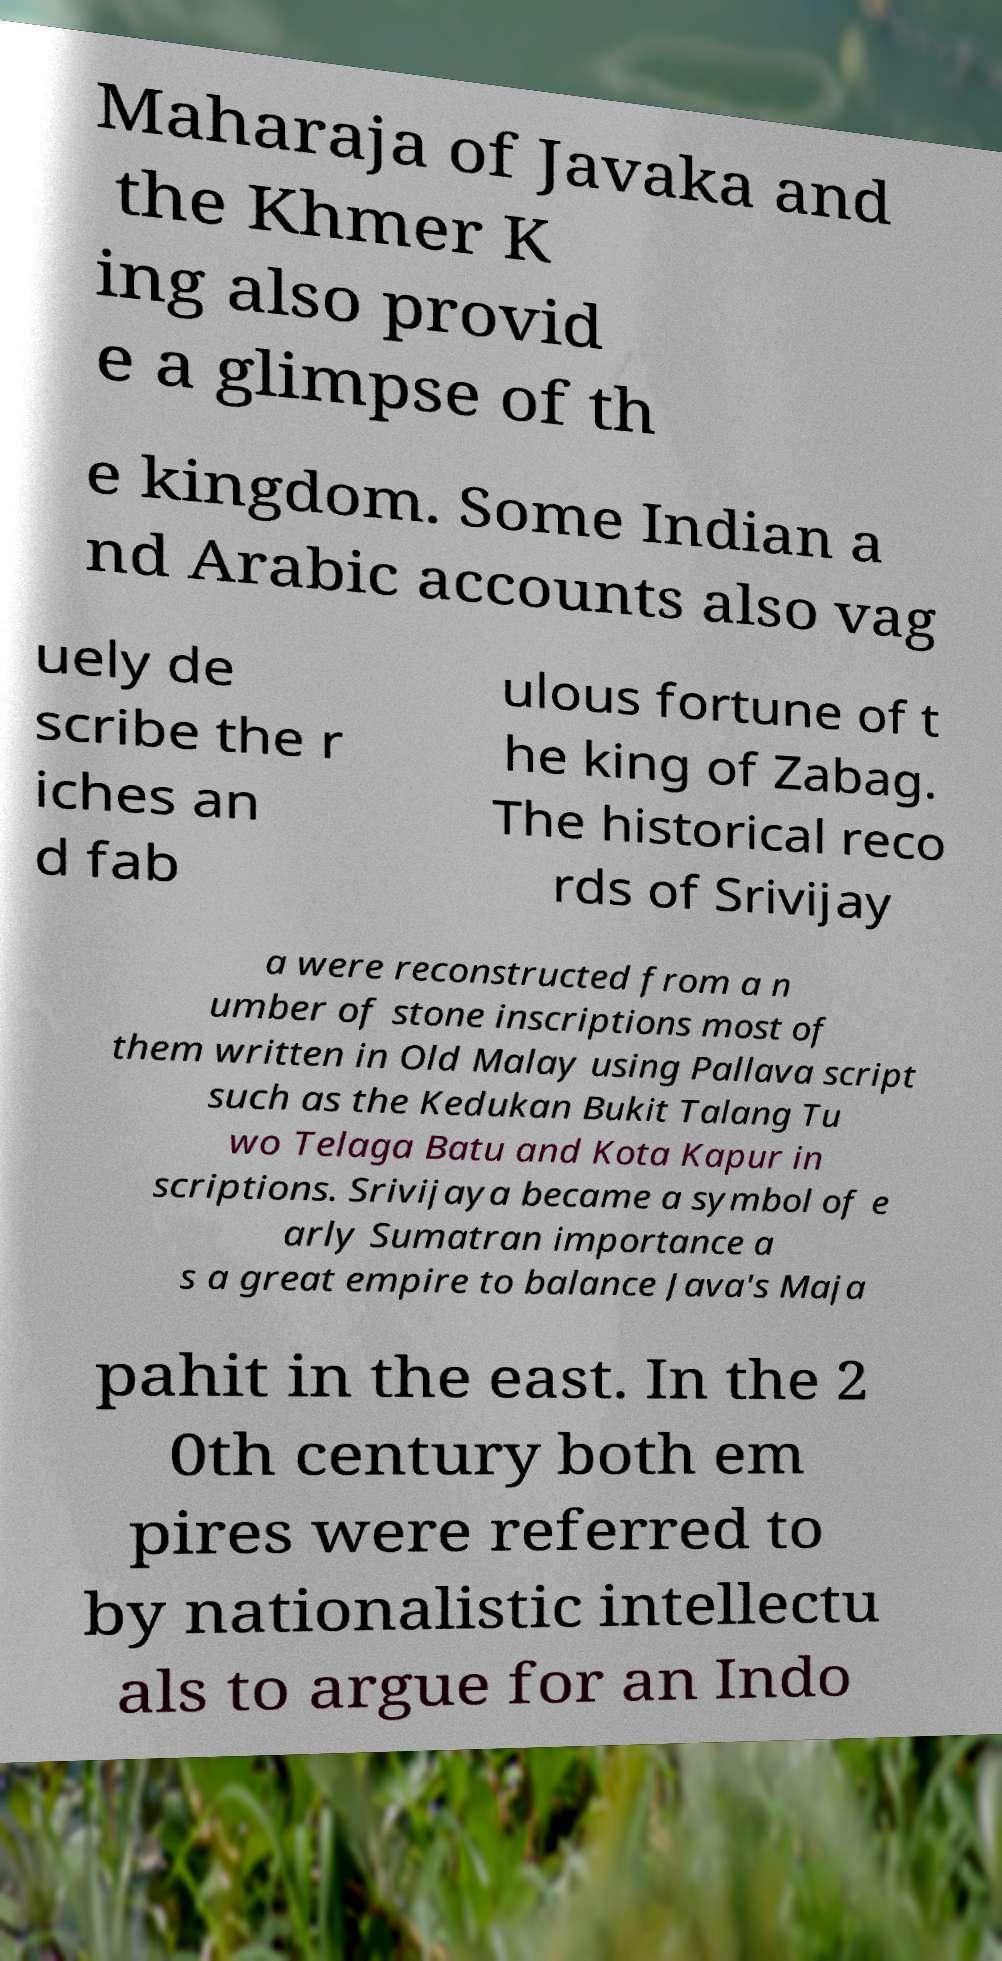What messages or text are displayed in this image? I need them in a readable, typed format. Maharaja of Javaka and the Khmer K ing also provid e a glimpse of th e kingdom. Some Indian a nd Arabic accounts also vag uely de scribe the r iches an d fab ulous fortune of t he king of Zabag. The historical reco rds of Srivijay a were reconstructed from a n umber of stone inscriptions most of them written in Old Malay using Pallava script such as the Kedukan Bukit Talang Tu wo Telaga Batu and Kota Kapur in scriptions. Srivijaya became a symbol of e arly Sumatran importance a s a great empire to balance Java's Maja pahit in the east. In the 2 0th century both em pires were referred to by nationalistic intellectu als to argue for an Indo 